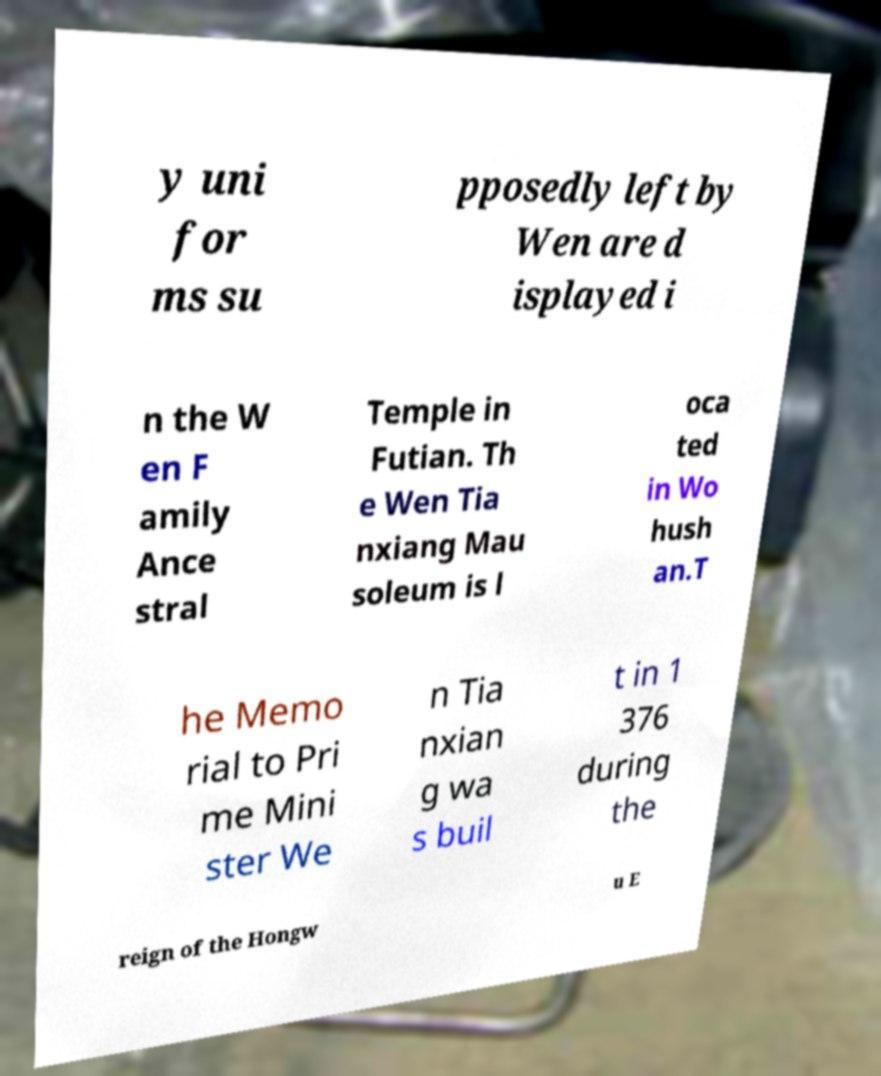Can you read and provide the text displayed in the image?This photo seems to have some interesting text. Can you extract and type it out for me? y uni for ms su pposedly left by Wen are d isplayed i n the W en F amily Ance stral Temple in Futian. Th e Wen Tia nxiang Mau soleum is l oca ted in Wo hush an.T he Memo rial to Pri me Mini ster We n Tia nxian g wa s buil t in 1 376 during the reign of the Hongw u E 